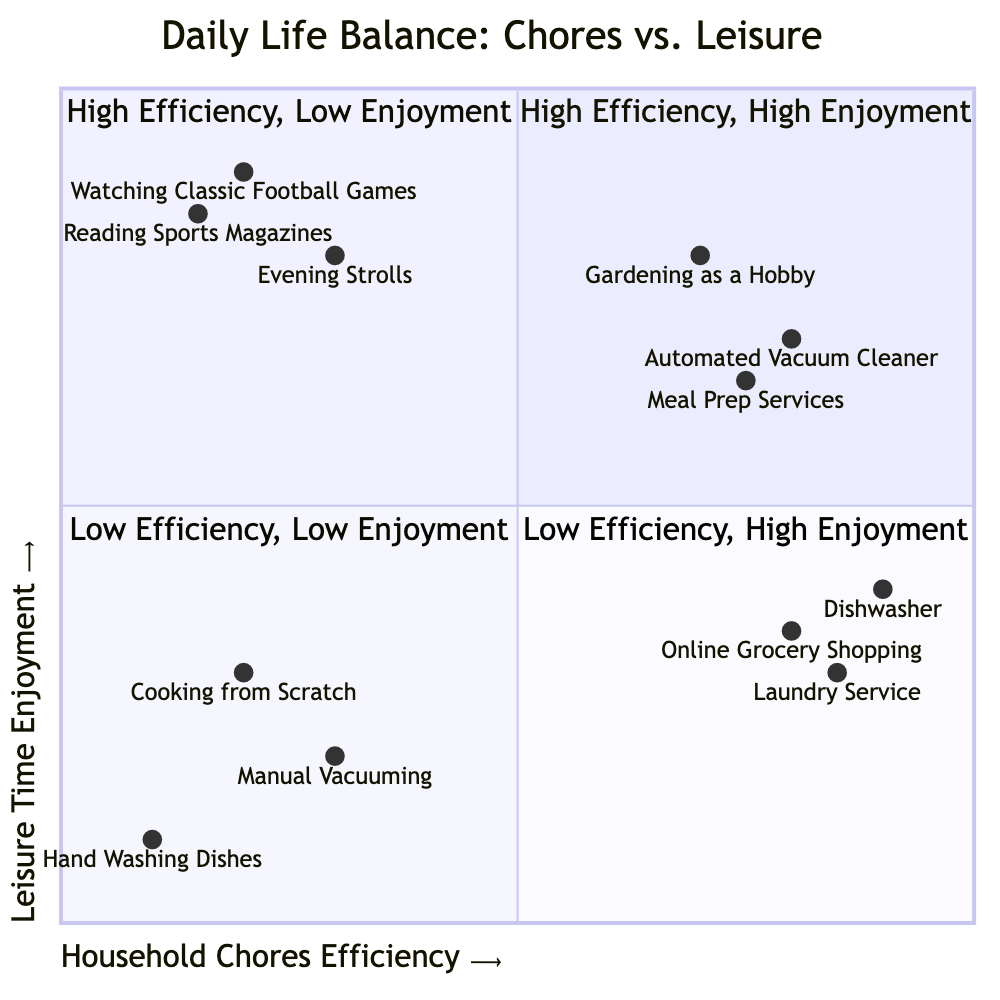What's in the "High Efficiency, High Enjoyment" quadrant? In the "High Efficiency, High Enjoyment" quadrant, the listed items are "Automated Vacuum Cleaner," "Meal Prep Services," and "Gardening as a Hobby." These are all activities that both increase efficiency in household chores and provide high leisure enjoyment.
Answer: Automated Vacuum Cleaner, Meal Prep Services, Gardening as a Hobby How many items are in the "Low Efficiency, Low Enjoyment" quadrant? The "Low Efficiency, Low Enjoyment" quadrant contains three items: "Manual Vacuuming," "Cooking from Scratch," and "Hand Washing Dishes." Therefore, this quadrant has a total of three items.
Answer: 3 Which activity has the highest household chores efficiency? Comparing all the items on the x-axis, "Dishwasher" is identified as having the highest household chores efficiency with a score of 0.9. This value represents its efficiency in completing household chores relative to the others.
Answer: Dishwasher What is the average leisure time enjoyment for items in the "High Efficiency, Low Enjoyment" quadrant? The items in this quadrant are "Dishwasher," "Laundry Service," and "Online Grocery Shopping." Their leisure time enjoyment values are 0.4, 0.3, and 0.35, respectively. Calculating the average: (0.4 + 0.3 + 0.35) / 3 = 0.35.
Answer: 0.35 Which quadrant includes activities that provide high leisure enjoyment but low efficiency in household chores? The "Low Chores Efficiency, High Leisure Enjoyment" quadrant contains activities that fit this description. The items in this quadrant are focused on leisure rather than efficiency in completing household chores.
Answer: Low Chores Efficiency, High Leisure Enjoyment What’s the relationship between “Watching Classic Football Games” and “Gardening as a Hobby” based on the quadrants? "Watching Classic Football Games" is located in the "Low Efficiency, High Leisure Enjoyment" quadrant, while "Gardening as a Hobby" is in the "High Efficiency, High Leisure Enjoyment" quadrant. Thus, they inhabit different quadrants that showcase contrasting ranges of household chores efficiency and leisure enjoyment.
Answer: Different quadrants How many total quadrants are there in this diagram? The diagram features four distinct quadrants, which categorize different activities based on their household chores efficiency and leisure enjoyment levels.
Answer: 4 Which item has the lowest leisure time enjoyment score? The item with the lowest leisure time enjoyment score is "Hand Washing Dishes," which is located in the "Low Efficiency, Low Enjoyment" quadrant with a score of 0.1.
Answer: Hand Washing Dishes What is the common theme of the top right quadrant? The common theme of the "High Efficiency, High Enjoyment" quadrant includes household activities that utilize technology or hobbies that increase efficiency in chores while maximizing leisure enjoyment, such as using an automated vacuum or meal prep services.
Answer: Technology and hobbies 